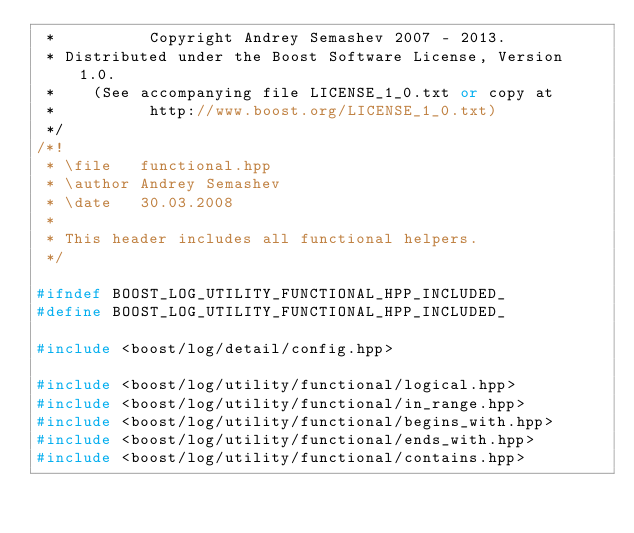<code> <loc_0><loc_0><loc_500><loc_500><_C++_> *          Copyright Andrey Semashev 2007 - 2013.
 * Distributed under the Boost Software License, Version 1.0.
 *    (See accompanying file LICENSE_1_0.txt or copy at
 *          http://www.boost.org/LICENSE_1_0.txt)
 */
/*!
 * \file   functional.hpp
 * \author Andrey Semashev
 * \date   30.03.2008
 *
 * This header includes all functional helpers.
 */

#ifndef BOOST_LOG_UTILITY_FUNCTIONAL_HPP_INCLUDED_
#define BOOST_LOG_UTILITY_FUNCTIONAL_HPP_INCLUDED_

#include <boost/log/detail/config.hpp>

#include <boost/log/utility/functional/logical.hpp>
#include <boost/log/utility/functional/in_range.hpp>
#include <boost/log/utility/functional/begins_with.hpp>
#include <boost/log/utility/functional/ends_with.hpp>
#include <boost/log/utility/functional/contains.hpp></code> 